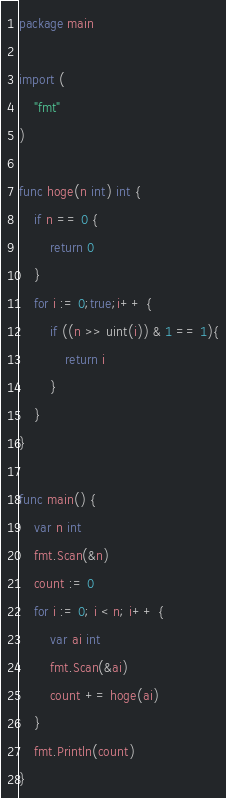Convert code to text. <code><loc_0><loc_0><loc_500><loc_500><_Go_>package main

import (
    "fmt"
)

func hoge(n int) int {
    if n == 0 {
        return 0
    }
    for i := 0;true;i++ {
        if ((n >> uint(i)) & 1 == 1){
            return i
        }
    }
}

func main() {
    var n int
    fmt.Scan(&n)
    count := 0
    for i := 0; i < n; i++ {
        var ai int
        fmt.Scan(&ai)
        count += hoge(ai)
    }
    fmt.Println(count)
}</code> 